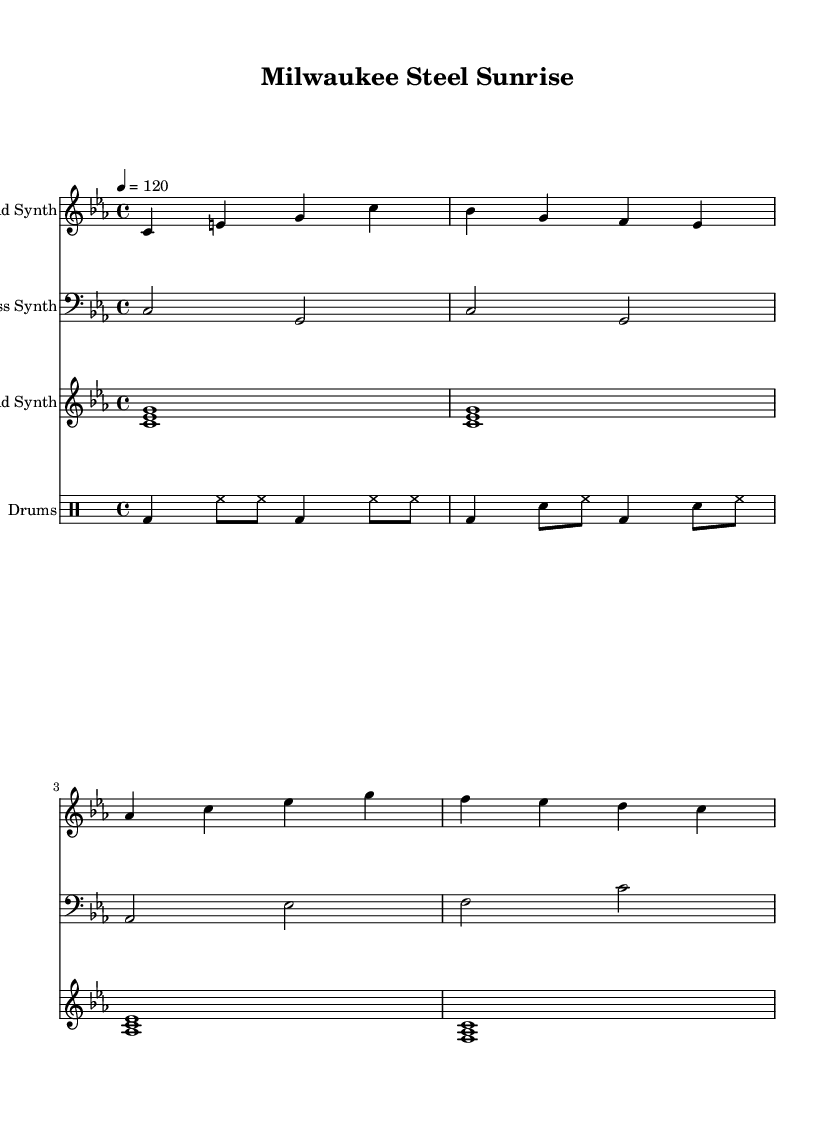What is the key signature of this music? The key signature is C minor, which has three flats (B flat, E flat, A flat).
Answer: C minor What is the time signature of this piece? The time signature is 4/4, indicating that there are four beats in each measure and a quarter note receives one beat.
Answer: 4/4 What is the tempo marking for this composition? The tempo marking is quarter note equals 120, indicating the speed at which the piece should be played.
Answer: 120 What is the instrument used for the lead synth? The lead synth is indicated by the staff labeled "Lead Synth" at the beginning of the score.
Answer: Lead Synth How many measures are present in the drum pattern? The drum pattern consists of four measures, as observed from the grouped rhythmic values written in the drum staff.
Answer: Four measures What type of synthesizer sound is indicated in the pad synth? The pad synth is represented by chords indicated as <c es g>, <as c es>, and <f as c> in the respective measures.
Answer: Chords What is the relationship between the bass synth notes and the lead synth in the composition? The bass synth notes provide harmonic support by playing lower frequencies that complement the melodic line of the lead synth.
Answer: Harmonic support 